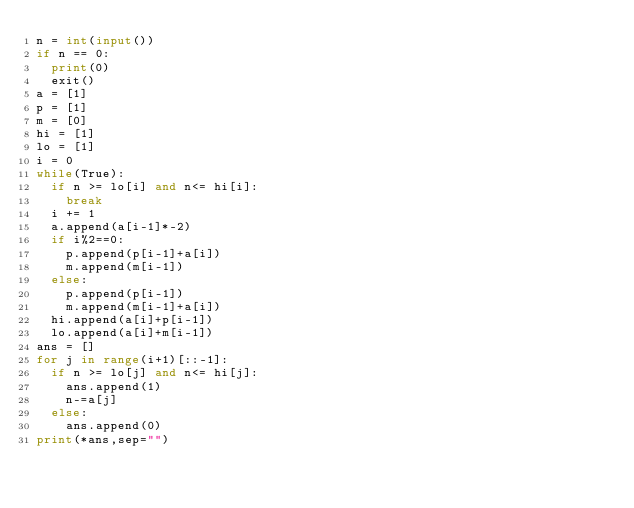<code> <loc_0><loc_0><loc_500><loc_500><_Python_>n = int(input())
if n == 0:
  print(0)
  exit()
a = [1]
p = [1]
m = [0]
hi = [1]
lo = [1]
i = 0
while(True):
  if n >= lo[i] and n<= hi[i]:
    break
  i += 1
  a.append(a[i-1]*-2)
  if i%2==0:
    p.append(p[i-1]+a[i])
    m.append(m[i-1])
  else:
    p.append(p[i-1])
    m.append(m[i-1]+a[i])
  hi.append(a[i]+p[i-1])
  lo.append(a[i]+m[i-1])
ans = []
for j in range(i+1)[::-1]:
  if n >= lo[j] and n<= hi[j]:
    ans.append(1)
    n-=a[j]
  else:
    ans.append(0)
print(*ans,sep="")</code> 